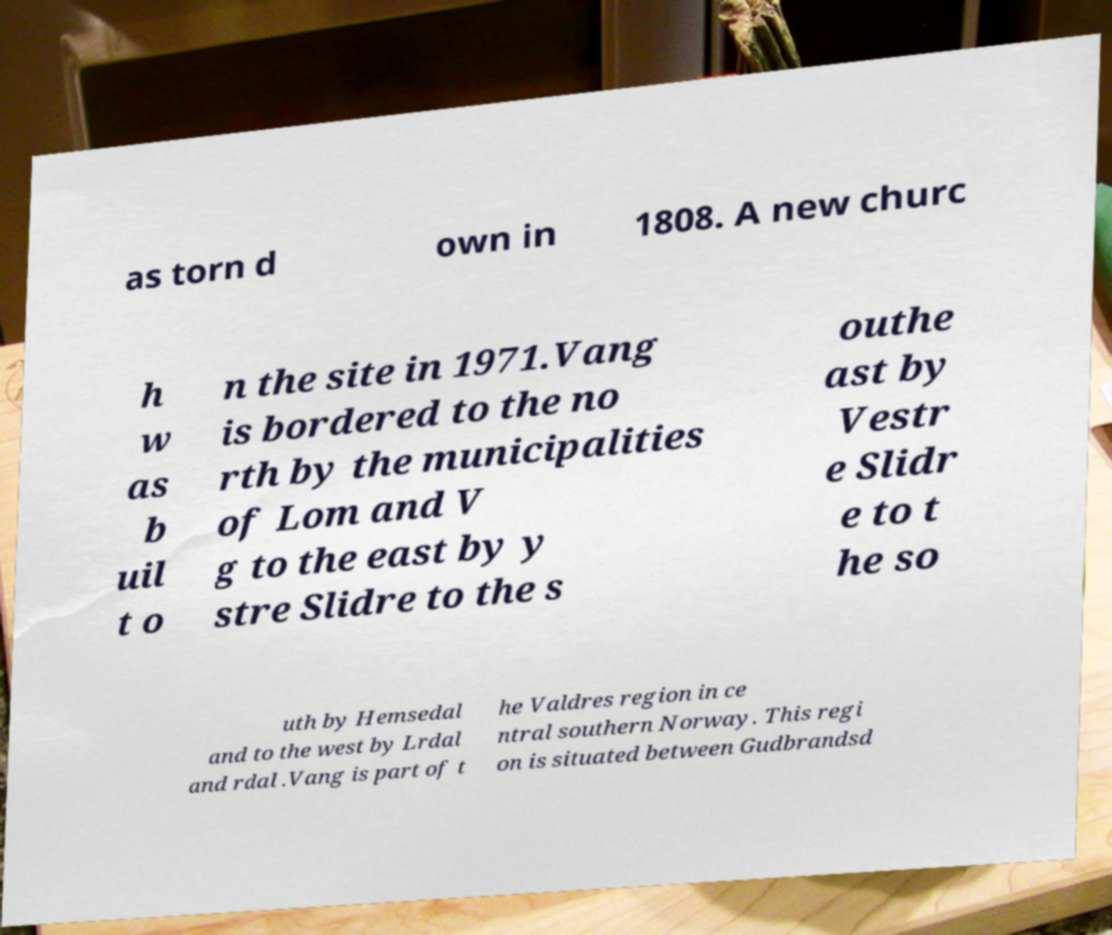Please read and relay the text visible in this image. What does it say? as torn d own in 1808. A new churc h w as b uil t o n the site in 1971.Vang is bordered to the no rth by the municipalities of Lom and V g to the east by y stre Slidre to the s outhe ast by Vestr e Slidr e to t he so uth by Hemsedal and to the west by Lrdal and rdal .Vang is part of t he Valdres region in ce ntral southern Norway. This regi on is situated between Gudbrandsd 